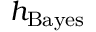<formula> <loc_0><loc_0><loc_500><loc_500>h _ { B a y e s }</formula> 